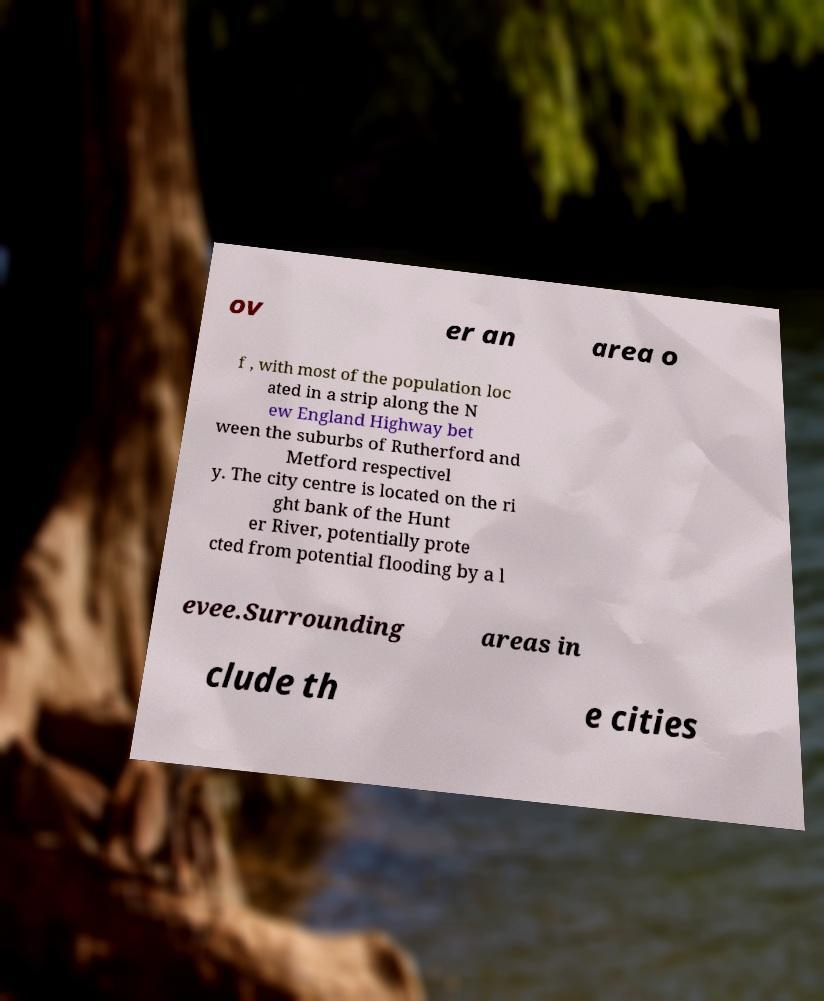For documentation purposes, I need the text within this image transcribed. Could you provide that? ov er an area o f , with most of the population loc ated in a strip along the N ew England Highway bet ween the suburbs of Rutherford and Metford respectivel y. The city centre is located on the ri ght bank of the Hunt er River, potentially prote cted from potential flooding by a l evee.Surrounding areas in clude th e cities 